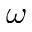<formula> <loc_0><loc_0><loc_500><loc_500>\omega</formula> 